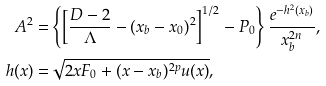<formula> <loc_0><loc_0><loc_500><loc_500>A ^ { 2 } = & \left \{ \left [ \frac { D - 2 } { \Lambda } - ( x _ { b } - x _ { 0 } ) ^ { 2 } \right ] ^ { 1 / 2 } - P _ { 0 } \right \} \frac { e ^ { - h ^ { 2 } ( x _ { b } ) } } { x _ { b } ^ { 2 n } } , \\ h ( x ) = & \sqrt { 2 x F _ { 0 } + ( x - x _ { b } ) ^ { 2 p } u ( x ) } ,</formula> 